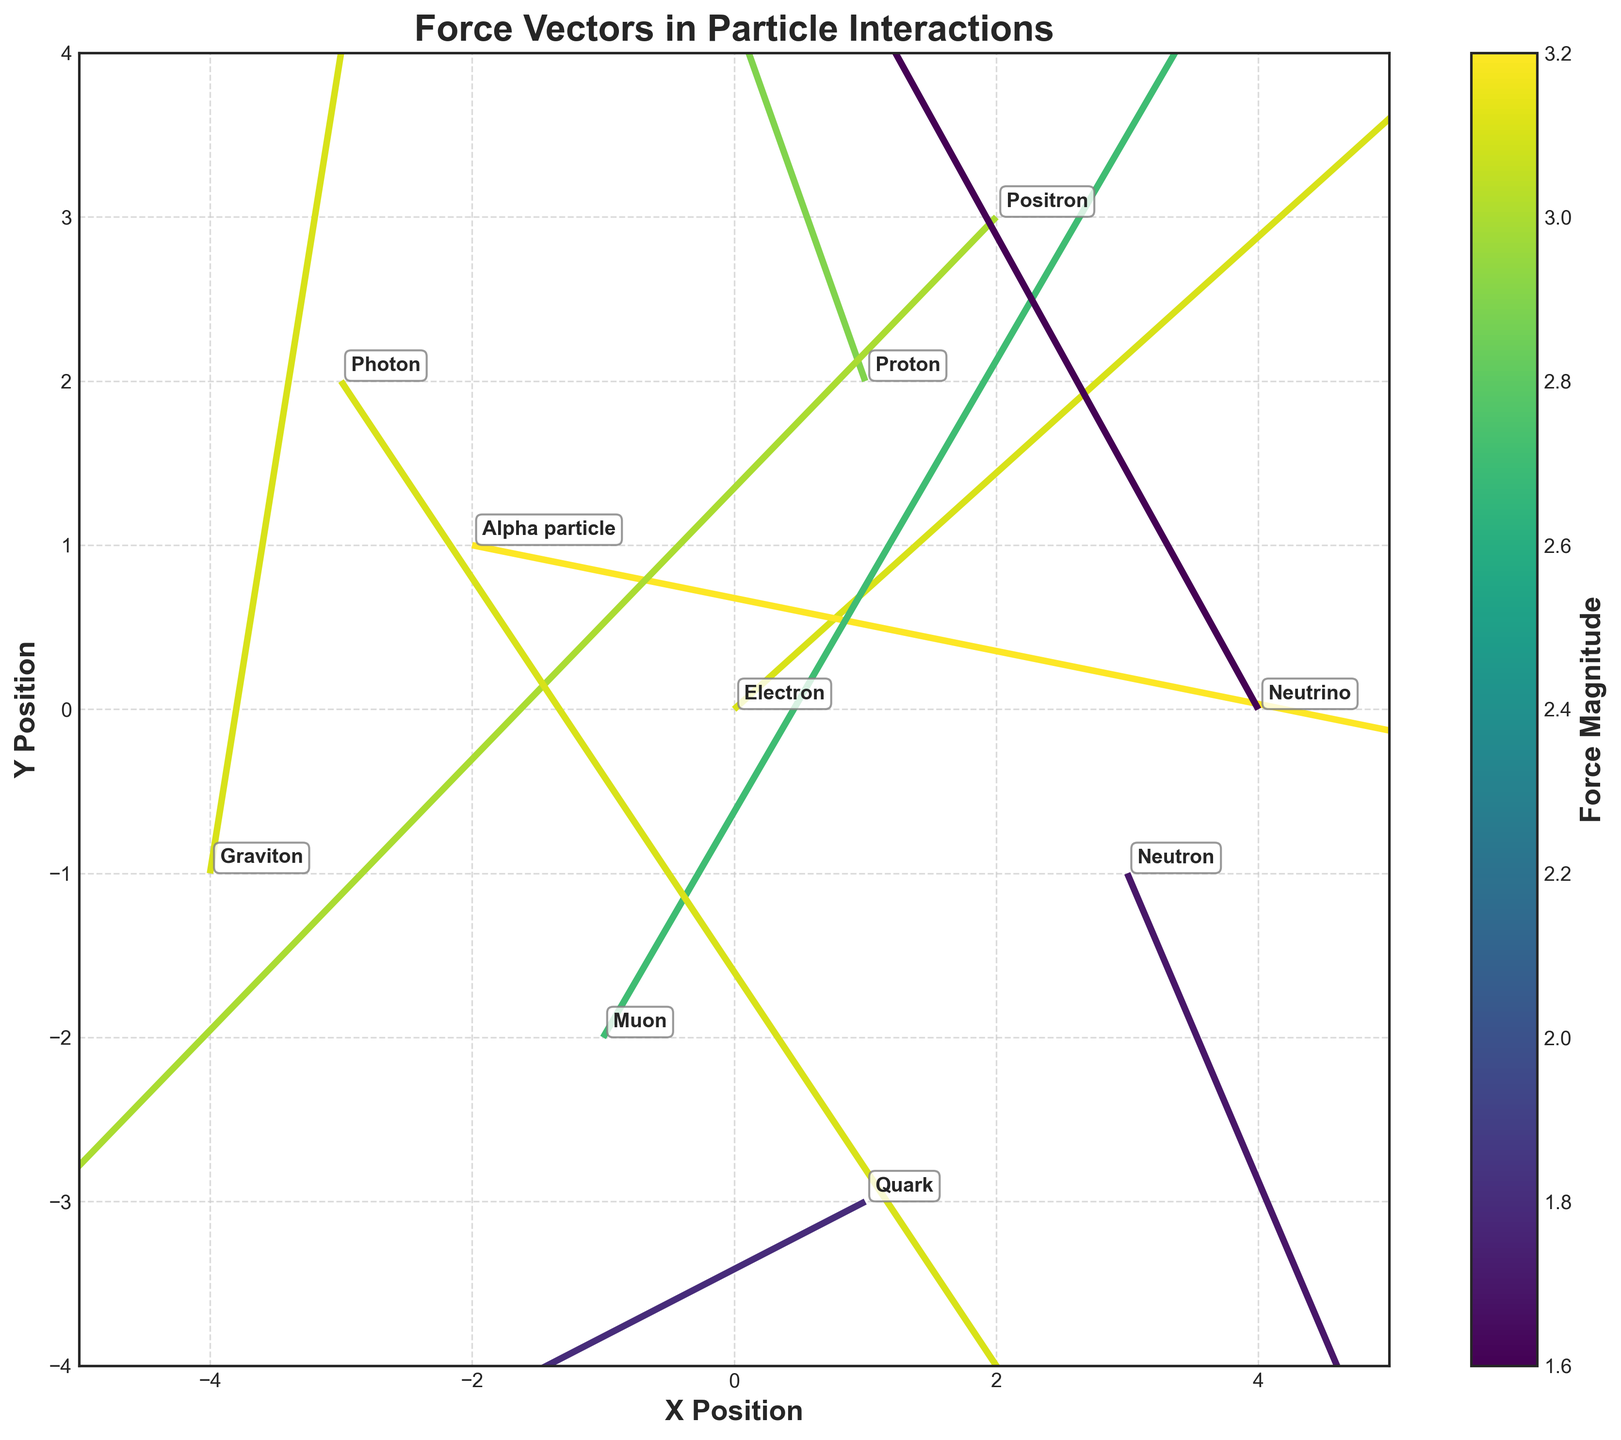What is the title of the figure? The title is found at the top of the plot and summarizes the overall focus of the plot. The title here is "Force Vectors in Particle Interactions."
Answer: Force Vectors in Particle Interactions Which particle has the highest force magnitude? Look at the color of the arrows and the colorbar; the darkest color, indicating the highest magnitude, corresponds to the "Alpha particle" at (x=-2, y=1).
Answer: Alpha particle What are the x and y limits of the plot? The x and y limits define the range of values shown on the axes of the plot. These values can be found by examining the axes directly. For x, it ranges from -5 to 5, and for y, it ranges from -4 to 4.
Answer: x: -5 to 5, y: -4 to 4 Which particle has a force vector pointing directly upward? By examining the direction of the arrows, the "Proton" at (x=1, y=2) has a force vector pointing almost directly upward (u=-1.2, v=2.7).
Answer: Proton How many particles are represented in the plot? Count the number of labeled points or arrows corresponding to particles in the plot. There are 10 particles listed in the data provided.
Answer: 10 What is the average force magnitude of the particles? Find the average by summing all the magnitudes and dividing by the number of particles. Sum the magnitudes (3.1 + 2.9 + 1.7 + 3.2 + 3.0 + 2.7 + 1.6 + 3.1 + 1.8 + 3.1) = 26.2, then divide by the number of particles, 10.
Answer: 2.62 Which particle has the smallest force vector? The smallest force vector has the lightest color on the arrow, indicating the lowest magnitude on the color bar. "Neutrino" at (x=4, y=0) has a magnitude of 1.6, which is the smallest.
Answer: Neutrino What is the direction of the "Photon" force vector? Observe the components of the vector (u and v) for the "Photon" at (x=-3, y=2). The components are (u=2.0, v=-2.4), this means it points approximately southeast.
Answer: Southeast Compare the force magnitudes of "Electron" and "Graviton" Find the magnitudes of both particles and compare them. "Electron" has a magnitude of 3.1, and "Graviton" has a magnitude of 3.1. Since both have the same magnitude, they are equal.
Answer: Equal Which particle is located at the origin? The location at the origin is where both x and y coordinates are zero. From the data, the "Electron" is at the origin (x=0, y=0).
Answer: Electron 